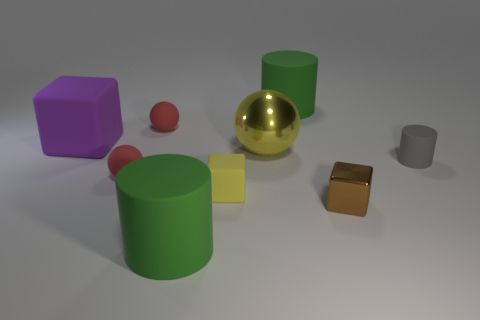Subtract all green cylinders. How many were subtracted if there are1green cylinders left? 1 Add 1 red rubber blocks. How many objects exist? 10 Subtract all cubes. How many objects are left? 6 Subtract all big blocks. Subtract all tiny brown blocks. How many objects are left? 7 Add 6 brown blocks. How many brown blocks are left? 7 Add 4 small yellow things. How many small yellow things exist? 5 Subtract 0 blue cylinders. How many objects are left? 9 